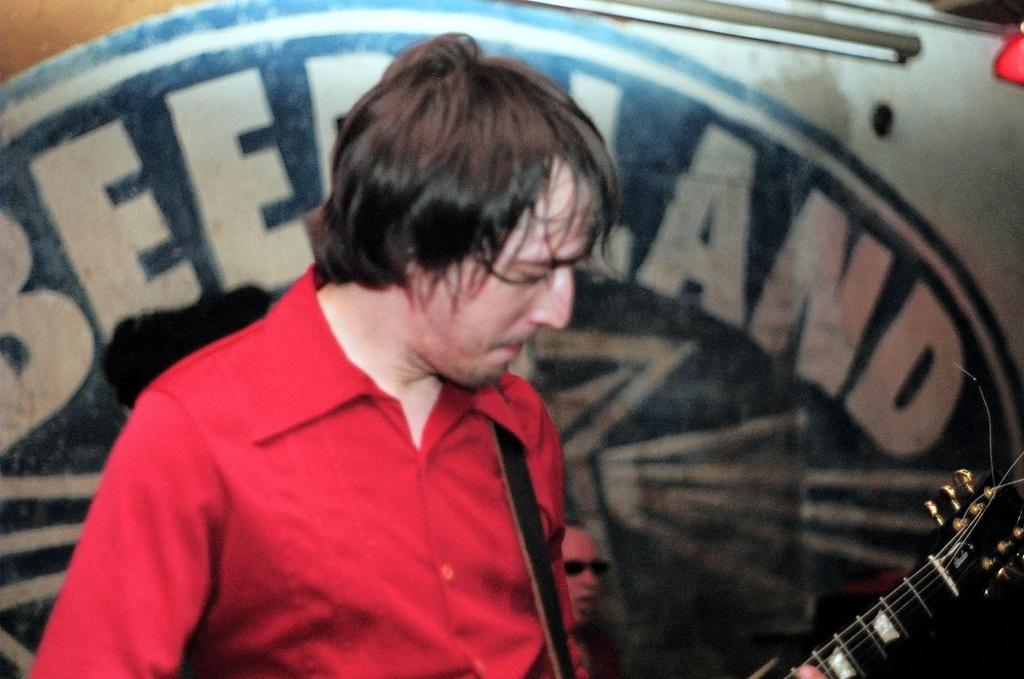Who is present in the image? There is a man in the image. What is the man wearing? The man is wearing a red shirt. What is the man holding in his hand? The man is holding a guitar in his hand. What type of crow is sitting on the man's shoulder in the image? There is no crow present in the image; the man is holding a guitar. 